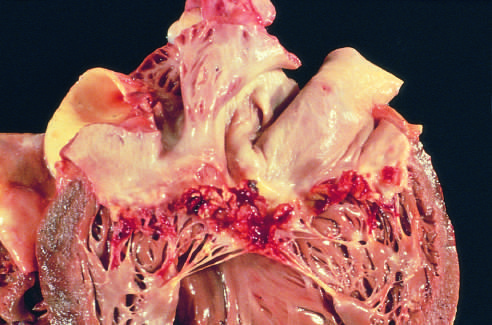what is caused by streptococcus viridans on a previously myxomatous mitral valve?
Answer the question using a single word or phrase. Subacute endocarditis 